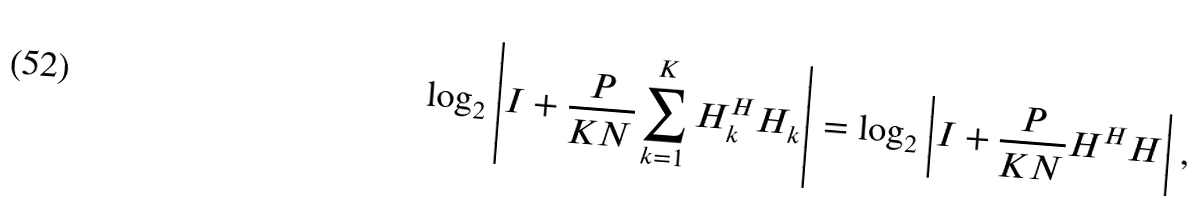<formula> <loc_0><loc_0><loc_500><loc_500>\log _ { 2 } \left | { I } + \frac { P } { K N } \sum _ { k = 1 } ^ { K } { H } _ { k } ^ { H } { H } _ { k } \right | = \log _ { 2 } \left | { I } + \frac { P } { K N } { H } ^ { H } { H } \right | ,</formula> 